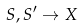<formula> <loc_0><loc_0><loc_500><loc_500>S , S ^ { \prime } \rightarrow X</formula> 